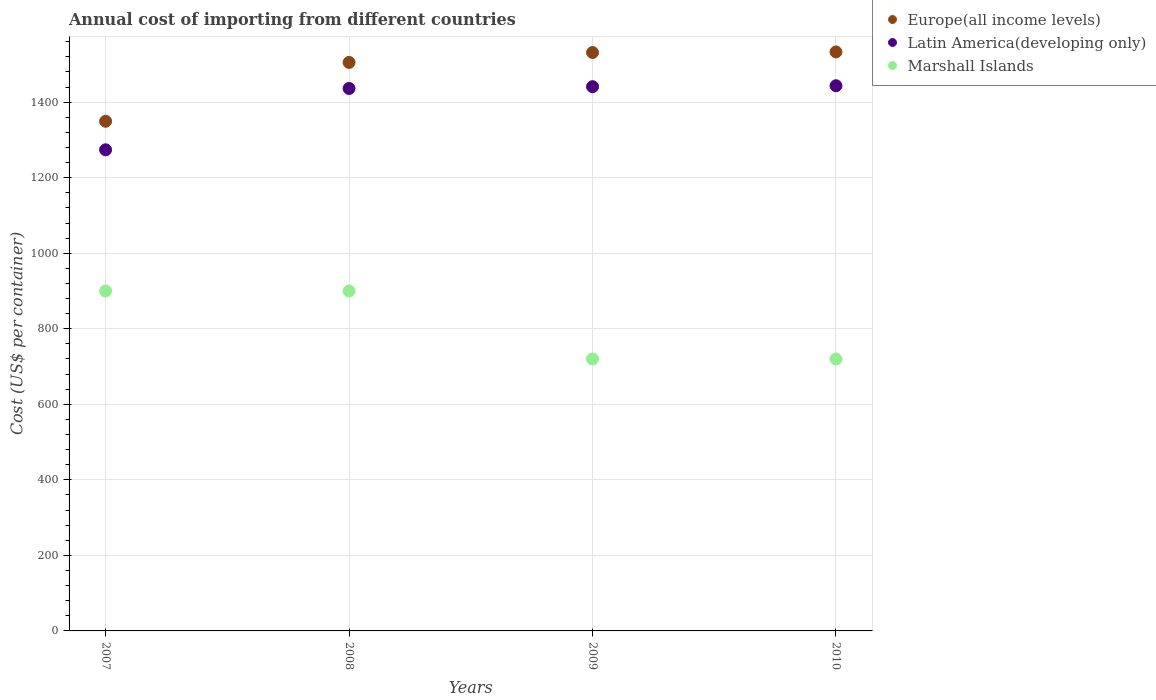Is the number of dotlines equal to the number of legend labels?
Your response must be concise. Yes. What is the total annual cost of importing in Europe(all income levels) in 2009?
Give a very brief answer. 1531.44. Across all years, what is the maximum total annual cost of importing in Europe(all income levels)?
Your response must be concise. 1532.98. Across all years, what is the minimum total annual cost of importing in Europe(all income levels)?
Ensure brevity in your answer.  1349.41. In which year was the total annual cost of importing in Europe(all income levels) maximum?
Keep it short and to the point. 2010. What is the total total annual cost of importing in Latin America(developing only) in the graph?
Your answer should be very brief. 5594.52. What is the difference between the total annual cost of importing in Marshall Islands in 2010 and the total annual cost of importing in Latin America(developing only) in 2008?
Your response must be concise. -716.22. What is the average total annual cost of importing in Europe(all income levels) per year?
Your response must be concise. 1479.75. In the year 2008, what is the difference between the total annual cost of importing in Europe(all income levels) and total annual cost of importing in Marshall Islands?
Make the answer very short. 605.17. In how many years, is the total annual cost of importing in Latin America(developing only) greater than 440 US$?
Give a very brief answer. 4. Is the total annual cost of importing in Europe(all income levels) in 2007 less than that in 2009?
Your response must be concise. Yes. What is the difference between the highest and the lowest total annual cost of importing in Marshall Islands?
Provide a succinct answer. 180. Is the sum of the total annual cost of importing in Europe(all income levels) in 2007 and 2009 greater than the maximum total annual cost of importing in Latin America(developing only) across all years?
Offer a very short reply. Yes. Is it the case that in every year, the sum of the total annual cost of importing in Latin America(developing only) and total annual cost of importing in Europe(all income levels)  is greater than the total annual cost of importing in Marshall Islands?
Provide a short and direct response. Yes. Is the total annual cost of importing in Latin America(developing only) strictly greater than the total annual cost of importing in Europe(all income levels) over the years?
Offer a terse response. No. What is the difference between two consecutive major ticks on the Y-axis?
Your answer should be compact. 200. Does the graph contain any zero values?
Your answer should be compact. No. Does the graph contain grids?
Offer a very short reply. Yes. Where does the legend appear in the graph?
Your answer should be very brief. Top right. How many legend labels are there?
Your answer should be compact. 3. How are the legend labels stacked?
Offer a terse response. Vertical. What is the title of the graph?
Your answer should be very brief. Annual cost of importing from different countries. Does "East Asia (developing only)" appear as one of the legend labels in the graph?
Offer a terse response. No. What is the label or title of the X-axis?
Offer a terse response. Years. What is the label or title of the Y-axis?
Keep it short and to the point. Cost (US$ per container). What is the Cost (US$ per container) of Europe(all income levels) in 2007?
Your response must be concise. 1349.41. What is the Cost (US$ per container) in Latin America(developing only) in 2007?
Make the answer very short. 1273.87. What is the Cost (US$ per container) of Marshall Islands in 2007?
Your answer should be very brief. 900. What is the Cost (US$ per container) of Europe(all income levels) in 2008?
Provide a succinct answer. 1505.17. What is the Cost (US$ per container) of Latin America(developing only) in 2008?
Your answer should be very brief. 1436.22. What is the Cost (US$ per container) in Marshall Islands in 2008?
Keep it short and to the point. 900. What is the Cost (US$ per container) in Europe(all income levels) in 2009?
Offer a terse response. 1531.44. What is the Cost (US$ per container) in Latin America(developing only) in 2009?
Give a very brief answer. 1441. What is the Cost (US$ per container) of Marshall Islands in 2009?
Keep it short and to the point. 720. What is the Cost (US$ per container) in Europe(all income levels) in 2010?
Ensure brevity in your answer.  1532.98. What is the Cost (US$ per container) in Latin America(developing only) in 2010?
Your response must be concise. 1443.43. What is the Cost (US$ per container) of Marshall Islands in 2010?
Your response must be concise. 720. Across all years, what is the maximum Cost (US$ per container) in Europe(all income levels)?
Provide a succinct answer. 1532.98. Across all years, what is the maximum Cost (US$ per container) in Latin America(developing only)?
Make the answer very short. 1443.43. Across all years, what is the maximum Cost (US$ per container) of Marshall Islands?
Your answer should be compact. 900. Across all years, what is the minimum Cost (US$ per container) of Europe(all income levels)?
Offer a terse response. 1349.41. Across all years, what is the minimum Cost (US$ per container) in Latin America(developing only)?
Your answer should be compact. 1273.87. Across all years, what is the minimum Cost (US$ per container) in Marshall Islands?
Make the answer very short. 720. What is the total Cost (US$ per container) of Europe(all income levels) in the graph?
Keep it short and to the point. 5919. What is the total Cost (US$ per container) of Latin America(developing only) in the graph?
Ensure brevity in your answer.  5594.52. What is the total Cost (US$ per container) of Marshall Islands in the graph?
Ensure brevity in your answer.  3240. What is the difference between the Cost (US$ per container) in Europe(all income levels) in 2007 and that in 2008?
Your response must be concise. -155.76. What is the difference between the Cost (US$ per container) of Latin America(developing only) in 2007 and that in 2008?
Your response must be concise. -162.35. What is the difference between the Cost (US$ per container) in Marshall Islands in 2007 and that in 2008?
Your answer should be compact. 0. What is the difference between the Cost (US$ per container) of Europe(all income levels) in 2007 and that in 2009?
Make the answer very short. -182.02. What is the difference between the Cost (US$ per container) of Latin America(developing only) in 2007 and that in 2009?
Make the answer very short. -167.13. What is the difference between the Cost (US$ per container) of Marshall Islands in 2007 and that in 2009?
Your answer should be compact. 180. What is the difference between the Cost (US$ per container) of Europe(all income levels) in 2007 and that in 2010?
Ensure brevity in your answer.  -183.57. What is the difference between the Cost (US$ per container) of Latin America(developing only) in 2007 and that in 2010?
Ensure brevity in your answer.  -169.57. What is the difference between the Cost (US$ per container) of Marshall Islands in 2007 and that in 2010?
Offer a terse response. 180. What is the difference between the Cost (US$ per container) in Europe(all income levels) in 2008 and that in 2009?
Provide a succinct answer. -26.27. What is the difference between the Cost (US$ per container) in Latin America(developing only) in 2008 and that in 2009?
Provide a short and direct response. -4.78. What is the difference between the Cost (US$ per container) of Marshall Islands in 2008 and that in 2009?
Offer a terse response. 180. What is the difference between the Cost (US$ per container) in Europe(all income levels) in 2008 and that in 2010?
Your answer should be compact. -27.81. What is the difference between the Cost (US$ per container) in Latin America(developing only) in 2008 and that in 2010?
Make the answer very short. -7.22. What is the difference between the Cost (US$ per container) in Marshall Islands in 2008 and that in 2010?
Offer a terse response. 180. What is the difference between the Cost (US$ per container) in Europe(all income levels) in 2009 and that in 2010?
Offer a very short reply. -1.54. What is the difference between the Cost (US$ per container) in Latin America(developing only) in 2009 and that in 2010?
Provide a short and direct response. -2.43. What is the difference between the Cost (US$ per container) of Europe(all income levels) in 2007 and the Cost (US$ per container) of Latin America(developing only) in 2008?
Make the answer very short. -86.8. What is the difference between the Cost (US$ per container) of Europe(all income levels) in 2007 and the Cost (US$ per container) of Marshall Islands in 2008?
Your answer should be very brief. 449.41. What is the difference between the Cost (US$ per container) of Latin America(developing only) in 2007 and the Cost (US$ per container) of Marshall Islands in 2008?
Make the answer very short. 373.87. What is the difference between the Cost (US$ per container) of Europe(all income levels) in 2007 and the Cost (US$ per container) of Latin America(developing only) in 2009?
Provide a short and direct response. -91.59. What is the difference between the Cost (US$ per container) in Europe(all income levels) in 2007 and the Cost (US$ per container) in Marshall Islands in 2009?
Your response must be concise. 629.41. What is the difference between the Cost (US$ per container) in Latin America(developing only) in 2007 and the Cost (US$ per container) in Marshall Islands in 2009?
Your answer should be compact. 553.87. What is the difference between the Cost (US$ per container) in Europe(all income levels) in 2007 and the Cost (US$ per container) in Latin America(developing only) in 2010?
Offer a terse response. -94.02. What is the difference between the Cost (US$ per container) of Europe(all income levels) in 2007 and the Cost (US$ per container) of Marshall Islands in 2010?
Keep it short and to the point. 629.41. What is the difference between the Cost (US$ per container) in Latin America(developing only) in 2007 and the Cost (US$ per container) in Marshall Islands in 2010?
Make the answer very short. 553.87. What is the difference between the Cost (US$ per container) of Europe(all income levels) in 2008 and the Cost (US$ per container) of Latin America(developing only) in 2009?
Make the answer very short. 64.17. What is the difference between the Cost (US$ per container) in Europe(all income levels) in 2008 and the Cost (US$ per container) in Marshall Islands in 2009?
Offer a terse response. 785.17. What is the difference between the Cost (US$ per container) in Latin America(developing only) in 2008 and the Cost (US$ per container) in Marshall Islands in 2009?
Keep it short and to the point. 716.22. What is the difference between the Cost (US$ per container) in Europe(all income levels) in 2008 and the Cost (US$ per container) in Latin America(developing only) in 2010?
Your answer should be compact. 61.74. What is the difference between the Cost (US$ per container) in Europe(all income levels) in 2008 and the Cost (US$ per container) in Marshall Islands in 2010?
Offer a terse response. 785.17. What is the difference between the Cost (US$ per container) of Latin America(developing only) in 2008 and the Cost (US$ per container) of Marshall Islands in 2010?
Keep it short and to the point. 716.22. What is the difference between the Cost (US$ per container) of Europe(all income levels) in 2009 and the Cost (US$ per container) of Latin America(developing only) in 2010?
Give a very brief answer. 88. What is the difference between the Cost (US$ per container) of Europe(all income levels) in 2009 and the Cost (US$ per container) of Marshall Islands in 2010?
Ensure brevity in your answer.  811.44. What is the difference between the Cost (US$ per container) in Latin America(developing only) in 2009 and the Cost (US$ per container) in Marshall Islands in 2010?
Keep it short and to the point. 721. What is the average Cost (US$ per container) of Europe(all income levels) per year?
Your response must be concise. 1479.75. What is the average Cost (US$ per container) in Latin America(developing only) per year?
Give a very brief answer. 1398.63. What is the average Cost (US$ per container) in Marshall Islands per year?
Offer a very short reply. 810. In the year 2007, what is the difference between the Cost (US$ per container) of Europe(all income levels) and Cost (US$ per container) of Latin America(developing only)?
Provide a short and direct response. 75.54. In the year 2007, what is the difference between the Cost (US$ per container) of Europe(all income levels) and Cost (US$ per container) of Marshall Islands?
Keep it short and to the point. 449.41. In the year 2007, what is the difference between the Cost (US$ per container) in Latin America(developing only) and Cost (US$ per container) in Marshall Islands?
Offer a terse response. 373.87. In the year 2008, what is the difference between the Cost (US$ per container) in Europe(all income levels) and Cost (US$ per container) in Latin America(developing only)?
Offer a very short reply. 68.95. In the year 2008, what is the difference between the Cost (US$ per container) of Europe(all income levels) and Cost (US$ per container) of Marshall Islands?
Give a very brief answer. 605.17. In the year 2008, what is the difference between the Cost (US$ per container) in Latin America(developing only) and Cost (US$ per container) in Marshall Islands?
Offer a terse response. 536.22. In the year 2009, what is the difference between the Cost (US$ per container) of Europe(all income levels) and Cost (US$ per container) of Latin America(developing only)?
Keep it short and to the point. 90.44. In the year 2009, what is the difference between the Cost (US$ per container) of Europe(all income levels) and Cost (US$ per container) of Marshall Islands?
Make the answer very short. 811.44. In the year 2009, what is the difference between the Cost (US$ per container) in Latin America(developing only) and Cost (US$ per container) in Marshall Islands?
Ensure brevity in your answer.  721. In the year 2010, what is the difference between the Cost (US$ per container) in Europe(all income levels) and Cost (US$ per container) in Latin America(developing only)?
Keep it short and to the point. 89.54. In the year 2010, what is the difference between the Cost (US$ per container) of Europe(all income levels) and Cost (US$ per container) of Marshall Islands?
Your answer should be compact. 812.98. In the year 2010, what is the difference between the Cost (US$ per container) in Latin America(developing only) and Cost (US$ per container) in Marshall Islands?
Offer a very short reply. 723.43. What is the ratio of the Cost (US$ per container) of Europe(all income levels) in 2007 to that in 2008?
Provide a short and direct response. 0.9. What is the ratio of the Cost (US$ per container) in Latin America(developing only) in 2007 to that in 2008?
Keep it short and to the point. 0.89. What is the ratio of the Cost (US$ per container) in Europe(all income levels) in 2007 to that in 2009?
Give a very brief answer. 0.88. What is the ratio of the Cost (US$ per container) of Latin America(developing only) in 2007 to that in 2009?
Offer a very short reply. 0.88. What is the ratio of the Cost (US$ per container) of Marshall Islands in 2007 to that in 2009?
Your response must be concise. 1.25. What is the ratio of the Cost (US$ per container) in Europe(all income levels) in 2007 to that in 2010?
Keep it short and to the point. 0.88. What is the ratio of the Cost (US$ per container) in Latin America(developing only) in 2007 to that in 2010?
Your answer should be compact. 0.88. What is the ratio of the Cost (US$ per container) in Marshall Islands in 2007 to that in 2010?
Keep it short and to the point. 1.25. What is the ratio of the Cost (US$ per container) in Europe(all income levels) in 2008 to that in 2009?
Your response must be concise. 0.98. What is the ratio of the Cost (US$ per container) of Latin America(developing only) in 2008 to that in 2009?
Your answer should be very brief. 1. What is the ratio of the Cost (US$ per container) in Marshall Islands in 2008 to that in 2009?
Give a very brief answer. 1.25. What is the ratio of the Cost (US$ per container) of Europe(all income levels) in 2008 to that in 2010?
Your answer should be very brief. 0.98. What is the ratio of the Cost (US$ per container) in Latin America(developing only) in 2009 to that in 2010?
Your answer should be very brief. 1. What is the difference between the highest and the second highest Cost (US$ per container) of Europe(all income levels)?
Give a very brief answer. 1.54. What is the difference between the highest and the second highest Cost (US$ per container) of Latin America(developing only)?
Ensure brevity in your answer.  2.43. What is the difference between the highest and the second highest Cost (US$ per container) in Marshall Islands?
Your answer should be compact. 0. What is the difference between the highest and the lowest Cost (US$ per container) in Europe(all income levels)?
Your response must be concise. 183.57. What is the difference between the highest and the lowest Cost (US$ per container) of Latin America(developing only)?
Your response must be concise. 169.57. What is the difference between the highest and the lowest Cost (US$ per container) of Marshall Islands?
Offer a terse response. 180. 